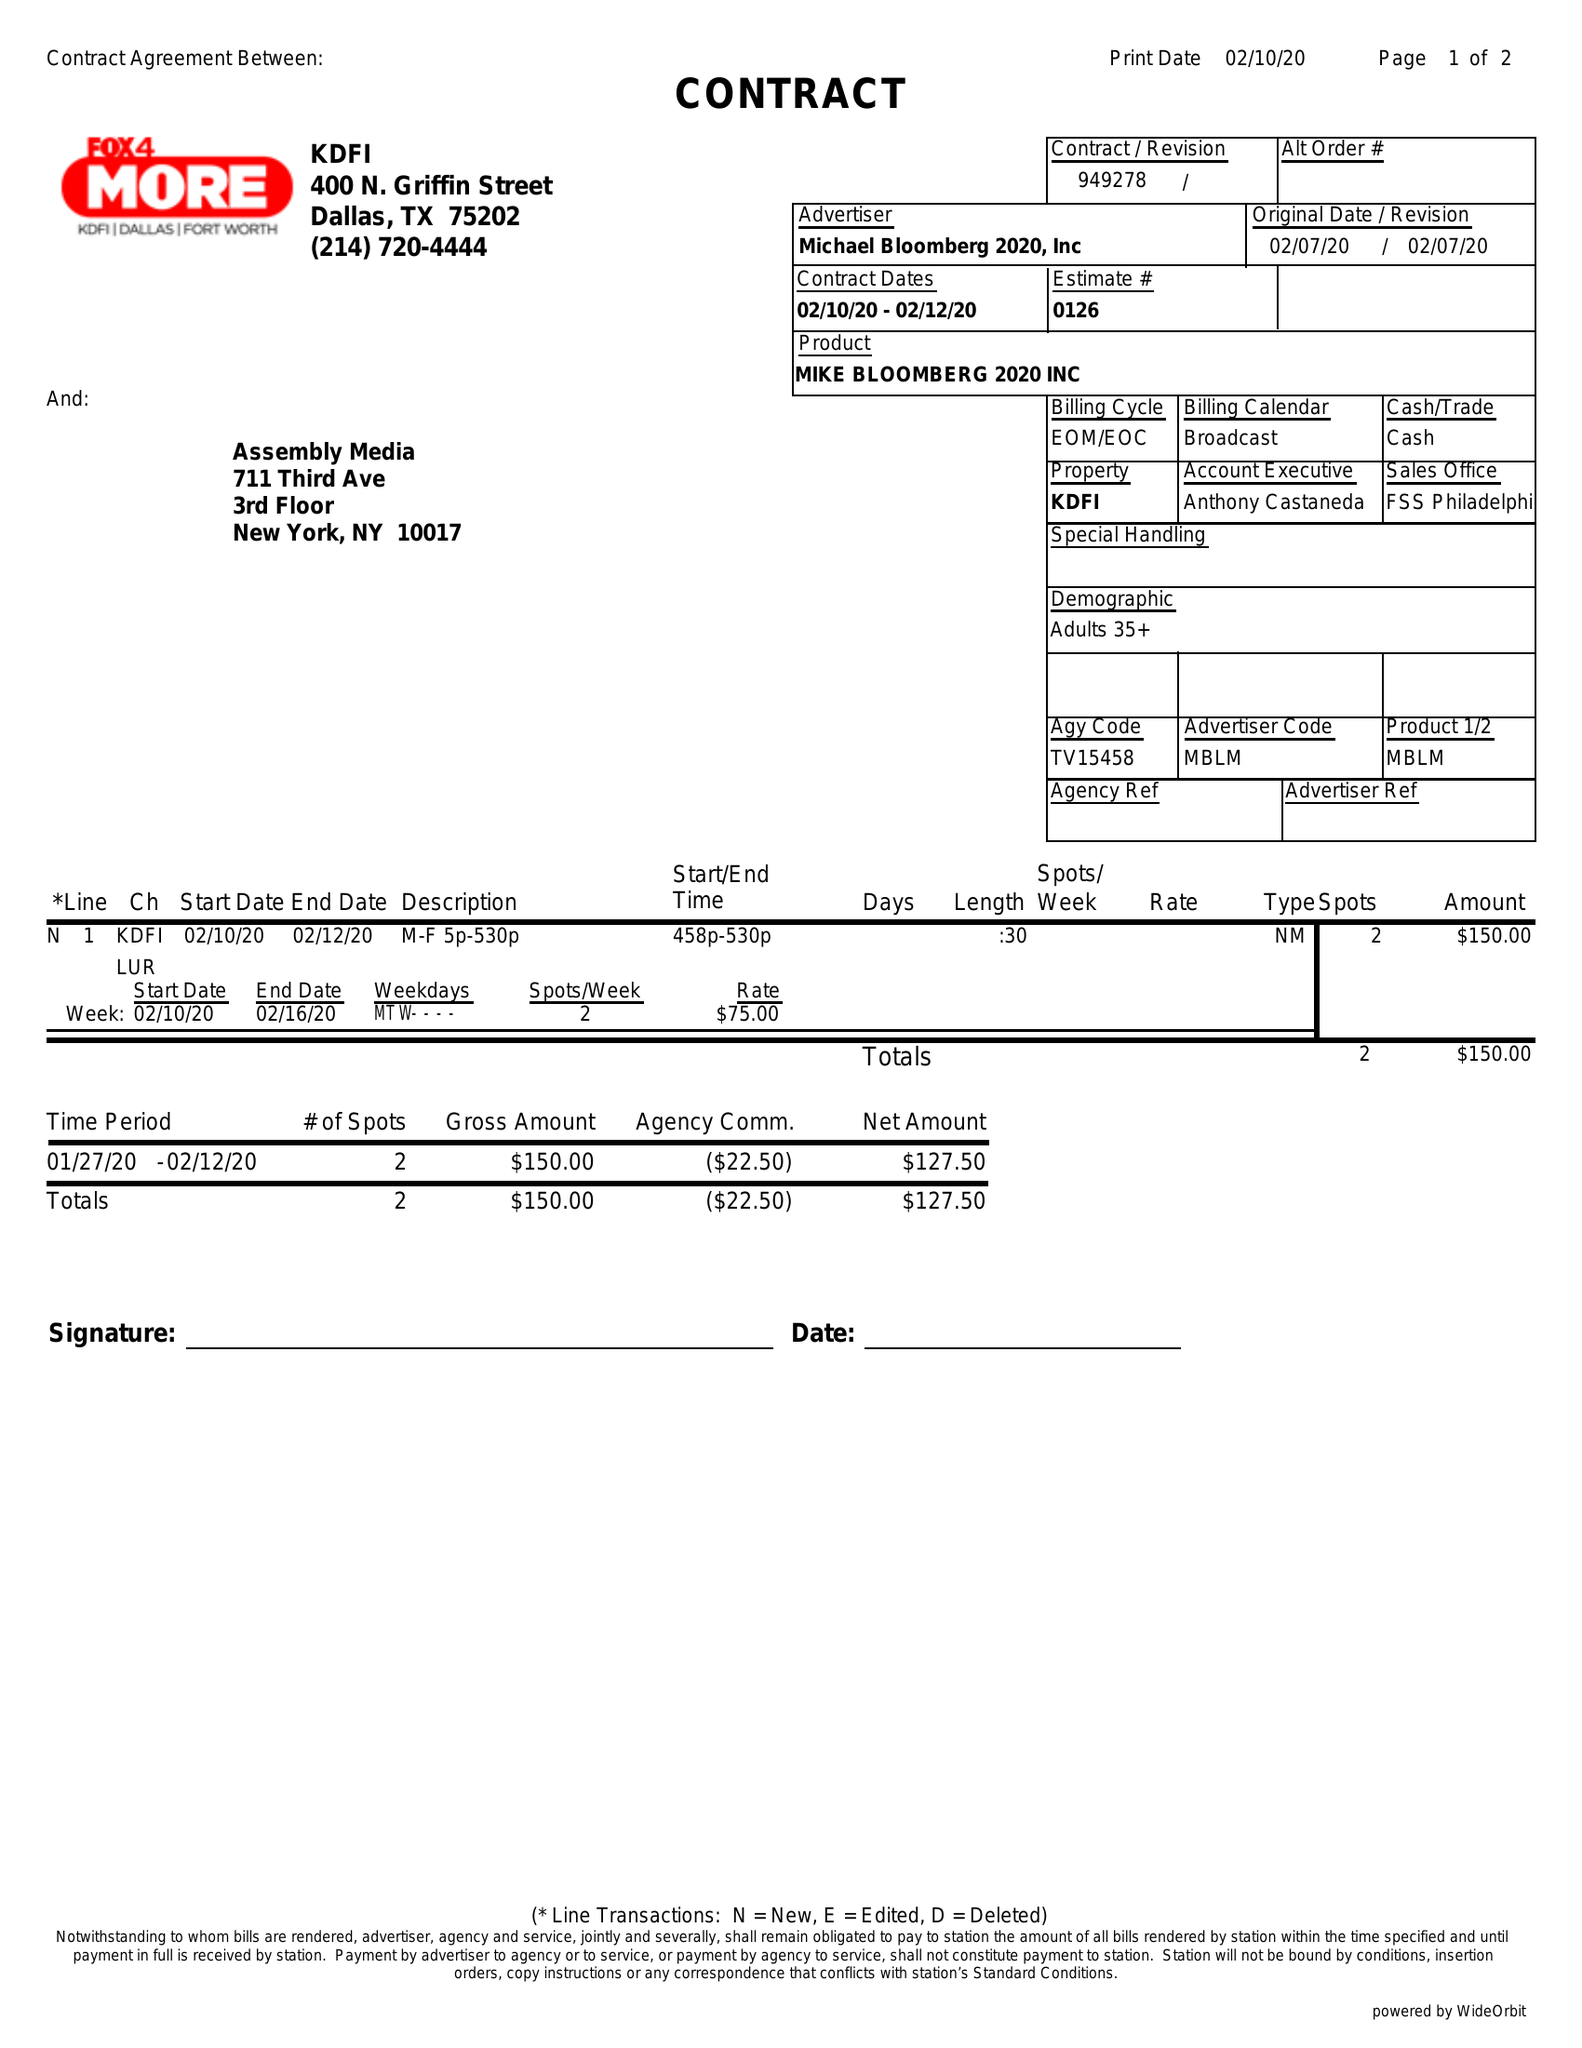What is the value for the gross_amount?
Answer the question using a single word or phrase. 150.00 